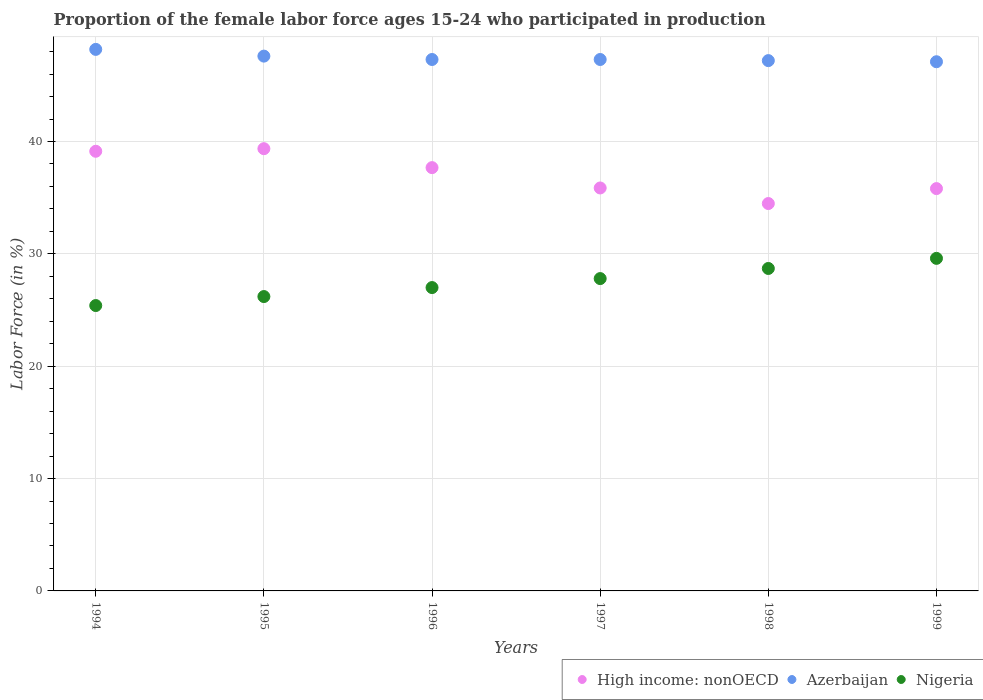How many different coloured dotlines are there?
Offer a very short reply. 3. Is the number of dotlines equal to the number of legend labels?
Your answer should be very brief. Yes. What is the proportion of the female labor force who participated in production in High income: nonOECD in 1998?
Provide a short and direct response. 34.48. Across all years, what is the maximum proportion of the female labor force who participated in production in Azerbaijan?
Your answer should be compact. 48.2. Across all years, what is the minimum proportion of the female labor force who participated in production in Nigeria?
Keep it short and to the point. 25.4. In which year was the proportion of the female labor force who participated in production in High income: nonOECD minimum?
Offer a terse response. 1998. What is the total proportion of the female labor force who participated in production in Nigeria in the graph?
Offer a terse response. 164.7. What is the difference between the proportion of the female labor force who participated in production in High income: nonOECD in 1997 and that in 1998?
Your answer should be very brief. 1.39. What is the difference between the proportion of the female labor force who participated in production in Nigeria in 1994 and the proportion of the female labor force who participated in production in High income: nonOECD in 1997?
Give a very brief answer. -10.47. What is the average proportion of the female labor force who participated in production in High income: nonOECD per year?
Your response must be concise. 37.05. In the year 1998, what is the difference between the proportion of the female labor force who participated in production in High income: nonOECD and proportion of the female labor force who participated in production in Azerbaijan?
Provide a succinct answer. -12.72. What is the ratio of the proportion of the female labor force who participated in production in Azerbaijan in 1995 to that in 1996?
Provide a short and direct response. 1.01. Is the proportion of the female labor force who participated in production in Nigeria in 1997 less than that in 1999?
Keep it short and to the point. Yes. What is the difference between the highest and the second highest proportion of the female labor force who participated in production in Azerbaijan?
Your response must be concise. 0.6. What is the difference between the highest and the lowest proportion of the female labor force who participated in production in Nigeria?
Provide a succinct answer. 4.2. Is the sum of the proportion of the female labor force who participated in production in High income: nonOECD in 1996 and 1999 greater than the maximum proportion of the female labor force who participated in production in Azerbaijan across all years?
Your response must be concise. Yes. Is it the case that in every year, the sum of the proportion of the female labor force who participated in production in High income: nonOECD and proportion of the female labor force who participated in production in Azerbaijan  is greater than the proportion of the female labor force who participated in production in Nigeria?
Your answer should be very brief. Yes. Does the proportion of the female labor force who participated in production in Azerbaijan monotonically increase over the years?
Give a very brief answer. No. How many dotlines are there?
Offer a terse response. 3. How many years are there in the graph?
Make the answer very short. 6. What is the difference between two consecutive major ticks on the Y-axis?
Ensure brevity in your answer.  10. Does the graph contain any zero values?
Provide a succinct answer. No. Where does the legend appear in the graph?
Your answer should be very brief. Bottom right. What is the title of the graph?
Keep it short and to the point. Proportion of the female labor force ages 15-24 who participated in production. Does "Seychelles" appear as one of the legend labels in the graph?
Keep it short and to the point. No. What is the label or title of the X-axis?
Make the answer very short. Years. What is the label or title of the Y-axis?
Ensure brevity in your answer.  Labor Force (in %). What is the Labor Force (in %) in High income: nonOECD in 1994?
Make the answer very short. 39.13. What is the Labor Force (in %) in Azerbaijan in 1994?
Provide a short and direct response. 48.2. What is the Labor Force (in %) of Nigeria in 1994?
Give a very brief answer. 25.4. What is the Labor Force (in %) in High income: nonOECD in 1995?
Make the answer very short. 39.36. What is the Labor Force (in %) of Azerbaijan in 1995?
Provide a short and direct response. 47.6. What is the Labor Force (in %) in Nigeria in 1995?
Your answer should be compact. 26.2. What is the Labor Force (in %) of High income: nonOECD in 1996?
Give a very brief answer. 37.68. What is the Labor Force (in %) of Azerbaijan in 1996?
Ensure brevity in your answer.  47.3. What is the Labor Force (in %) of Nigeria in 1996?
Your answer should be very brief. 27. What is the Labor Force (in %) of High income: nonOECD in 1997?
Your answer should be compact. 35.87. What is the Labor Force (in %) of Azerbaijan in 1997?
Make the answer very short. 47.3. What is the Labor Force (in %) of Nigeria in 1997?
Make the answer very short. 27.8. What is the Labor Force (in %) in High income: nonOECD in 1998?
Offer a very short reply. 34.48. What is the Labor Force (in %) of Azerbaijan in 1998?
Keep it short and to the point. 47.2. What is the Labor Force (in %) in Nigeria in 1998?
Give a very brief answer. 28.7. What is the Labor Force (in %) in High income: nonOECD in 1999?
Give a very brief answer. 35.81. What is the Labor Force (in %) of Azerbaijan in 1999?
Offer a terse response. 47.1. What is the Labor Force (in %) in Nigeria in 1999?
Offer a very short reply. 29.6. Across all years, what is the maximum Labor Force (in %) in High income: nonOECD?
Your answer should be compact. 39.36. Across all years, what is the maximum Labor Force (in %) of Azerbaijan?
Keep it short and to the point. 48.2. Across all years, what is the maximum Labor Force (in %) in Nigeria?
Make the answer very short. 29.6. Across all years, what is the minimum Labor Force (in %) in High income: nonOECD?
Ensure brevity in your answer.  34.48. Across all years, what is the minimum Labor Force (in %) of Azerbaijan?
Make the answer very short. 47.1. Across all years, what is the minimum Labor Force (in %) in Nigeria?
Provide a succinct answer. 25.4. What is the total Labor Force (in %) of High income: nonOECD in the graph?
Provide a succinct answer. 222.32. What is the total Labor Force (in %) of Azerbaijan in the graph?
Keep it short and to the point. 284.7. What is the total Labor Force (in %) of Nigeria in the graph?
Your response must be concise. 164.7. What is the difference between the Labor Force (in %) in High income: nonOECD in 1994 and that in 1995?
Give a very brief answer. -0.23. What is the difference between the Labor Force (in %) in Azerbaijan in 1994 and that in 1995?
Give a very brief answer. 0.6. What is the difference between the Labor Force (in %) in High income: nonOECD in 1994 and that in 1996?
Keep it short and to the point. 1.46. What is the difference between the Labor Force (in %) of Nigeria in 1994 and that in 1996?
Provide a succinct answer. -1.6. What is the difference between the Labor Force (in %) of High income: nonOECD in 1994 and that in 1997?
Your response must be concise. 3.27. What is the difference between the Labor Force (in %) of High income: nonOECD in 1994 and that in 1998?
Make the answer very short. 4.65. What is the difference between the Labor Force (in %) of Nigeria in 1994 and that in 1998?
Provide a succinct answer. -3.3. What is the difference between the Labor Force (in %) of High income: nonOECD in 1994 and that in 1999?
Make the answer very short. 3.32. What is the difference between the Labor Force (in %) in Azerbaijan in 1994 and that in 1999?
Offer a terse response. 1.1. What is the difference between the Labor Force (in %) in High income: nonOECD in 1995 and that in 1996?
Give a very brief answer. 1.69. What is the difference between the Labor Force (in %) in Azerbaijan in 1995 and that in 1996?
Provide a succinct answer. 0.3. What is the difference between the Labor Force (in %) in High income: nonOECD in 1995 and that in 1997?
Ensure brevity in your answer.  3.5. What is the difference between the Labor Force (in %) of Azerbaijan in 1995 and that in 1997?
Your answer should be very brief. 0.3. What is the difference between the Labor Force (in %) of High income: nonOECD in 1995 and that in 1998?
Offer a very short reply. 4.88. What is the difference between the Labor Force (in %) in Nigeria in 1995 and that in 1998?
Your answer should be compact. -2.5. What is the difference between the Labor Force (in %) in High income: nonOECD in 1995 and that in 1999?
Make the answer very short. 3.55. What is the difference between the Labor Force (in %) of Azerbaijan in 1995 and that in 1999?
Give a very brief answer. 0.5. What is the difference between the Labor Force (in %) in Nigeria in 1995 and that in 1999?
Offer a very short reply. -3.4. What is the difference between the Labor Force (in %) of High income: nonOECD in 1996 and that in 1997?
Offer a very short reply. 1.81. What is the difference between the Labor Force (in %) in High income: nonOECD in 1996 and that in 1998?
Offer a very short reply. 3.2. What is the difference between the Labor Force (in %) in Azerbaijan in 1996 and that in 1998?
Offer a very short reply. 0.1. What is the difference between the Labor Force (in %) of High income: nonOECD in 1996 and that in 1999?
Your answer should be compact. 1.87. What is the difference between the Labor Force (in %) of Nigeria in 1996 and that in 1999?
Offer a very short reply. -2.6. What is the difference between the Labor Force (in %) of High income: nonOECD in 1997 and that in 1998?
Your response must be concise. 1.39. What is the difference between the Labor Force (in %) of Azerbaijan in 1997 and that in 1998?
Provide a succinct answer. 0.1. What is the difference between the Labor Force (in %) in Nigeria in 1997 and that in 1998?
Offer a very short reply. -0.9. What is the difference between the Labor Force (in %) in High income: nonOECD in 1997 and that in 1999?
Your answer should be compact. 0.06. What is the difference between the Labor Force (in %) in Nigeria in 1997 and that in 1999?
Offer a terse response. -1.8. What is the difference between the Labor Force (in %) of High income: nonOECD in 1998 and that in 1999?
Provide a short and direct response. -1.33. What is the difference between the Labor Force (in %) of Azerbaijan in 1998 and that in 1999?
Provide a short and direct response. 0.1. What is the difference between the Labor Force (in %) of Nigeria in 1998 and that in 1999?
Keep it short and to the point. -0.9. What is the difference between the Labor Force (in %) in High income: nonOECD in 1994 and the Labor Force (in %) in Azerbaijan in 1995?
Your response must be concise. -8.47. What is the difference between the Labor Force (in %) in High income: nonOECD in 1994 and the Labor Force (in %) in Nigeria in 1995?
Give a very brief answer. 12.93. What is the difference between the Labor Force (in %) of Azerbaijan in 1994 and the Labor Force (in %) of Nigeria in 1995?
Provide a short and direct response. 22. What is the difference between the Labor Force (in %) of High income: nonOECD in 1994 and the Labor Force (in %) of Azerbaijan in 1996?
Provide a succinct answer. -8.17. What is the difference between the Labor Force (in %) in High income: nonOECD in 1994 and the Labor Force (in %) in Nigeria in 1996?
Give a very brief answer. 12.13. What is the difference between the Labor Force (in %) in Azerbaijan in 1994 and the Labor Force (in %) in Nigeria in 1996?
Provide a succinct answer. 21.2. What is the difference between the Labor Force (in %) of High income: nonOECD in 1994 and the Labor Force (in %) of Azerbaijan in 1997?
Provide a short and direct response. -8.17. What is the difference between the Labor Force (in %) of High income: nonOECD in 1994 and the Labor Force (in %) of Nigeria in 1997?
Your answer should be very brief. 11.33. What is the difference between the Labor Force (in %) in Azerbaijan in 1994 and the Labor Force (in %) in Nigeria in 1997?
Offer a terse response. 20.4. What is the difference between the Labor Force (in %) of High income: nonOECD in 1994 and the Labor Force (in %) of Azerbaijan in 1998?
Your answer should be very brief. -8.07. What is the difference between the Labor Force (in %) of High income: nonOECD in 1994 and the Labor Force (in %) of Nigeria in 1998?
Offer a terse response. 10.43. What is the difference between the Labor Force (in %) of High income: nonOECD in 1994 and the Labor Force (in %) of Azerbaijan in 1999?
Your answer should be very brief. -7.97. What is the difference between the Labor Force (in %) of High income: nonOECD in 1994 and the Labor Force (in %) of Nigeria in 1999?
Provide a succinct answer. 9.53. What is the difference between the Labor Force (in %) in High income: nonOECD in 1995 and the Labor Force (in %) in Azerbaijan in 1996?
Make the answer very short. -7.94. What is the difference between the Labor Force (in %) of High income: nonOECD in 1995 and the Labor Force (in %) of Nigeria in 1996?
Offer a very short reply. 12.36. What is the difference between the Labor Force (in %) of Azerbaijan in 1995 and the Labor Force (in %) of Nigeria in 1996?
Your answer should be compact. 20.6. What is the difference between the Labor Force (in %) in High income: nonOECD in 1995 and the Labor Force (in %) in Azerbaijan in 1997?
Give a very brief answer. -7.94. What is the difference between the Labor Force (in %) in High income: nonOECD in 1995 and the Labor Force (in %) in Nigeria in 1997?
Your answer should be compact. 11.56. What is the difference between the Labor Force (in %) of Azerbaijan in 1995 and the Labor Force (in %) of Nigeria in 1997?
Provide a succinct answer. 19.8. What is the difference between the Labor Force (in %) of High income: nonOECD in 1995 and the Labor Force (in %) of Azerbaijan in 1998?
Offer a terse response. -7.84. What is the difference between the Labor Force (in %) of High income: nonOECD in 1995 and the Labor Force (in %) of Nigeria in 1998?
Offer a very short reply. 10.66. What is the difference between the Labor Force (in %) of Azerbaijan in 1995 and the Labor Force (in %) of Nigeria in 1998?
Provide a succinct answer. 18.9. What is the difference between the Labor Force (in %) of High income: nonOECD in 1995 and the Labor Force (in %) of Azerbaijan in 1999?
Your response must be concise. -7.74. What is the difference between the Labor Force (in %) in High income: nonOECD in 1995 and the Labor Force (in %) in Nigeria in 1999?
Offer a terse response. 9.76. What is the difference between the Labor Force (in %) of High income: nonOECD in 1996 and the Labor Force (in %) of Azerbaijan in 1997?
Offer a terse response. -9.62. What is the difference between the Labor Force (in %) of High income: nonOECD in 1996 and the Labor Force (in %) of Nigeria in 1997?
Make the answer very short. 9.88. What is the difference between the Labor Force (in %) in Azerbaijan in 1996 and the Labor Force (in %) in Nigeria in 1997?
Offer a very short reply. 19.5. What is the difference between the Labor Force (in %) of High income: nonOECD in 1996 and the Labor Force (in %) of Azerbaijan in 1998?
Provide a short and direct response. -9.53. What is the difference between the Labor Force (in %) of High income: nonOECD in 1996 and the Labor Force (in %) of Nigeria in 1998?
Provide a short and direct response. 8.97. What is the difference between the Labor Force (in %) of Azerbaijan in 1996 and the Labor Force (in %) of Nigeria in 1998?
Provide a succinct answer. 18.6. What is the difference between the Labor Force (in %) of High income: nonOECD in 1996 and the Labor Force (in %) of Azerbaijan in 1999?
Ensure brevity in your answer.  -9.43. What is the difference between the Labor Force (in %) of High income: nonOECD in 1996 and the Labor Force (in %) of Nigeria in 1999?
Give a very brief answer. 8.07. What is the difference between the Labor Force (in %) in Azerbaijan in 1996 and the Labor Force (in %) in Nigeria in 1999?
Keep it short and to the point. 17.7. What is the difference between the Labor Force (in %) of High income: nonOECD in 1997 and the Labor Force (in %) of Azerbaijan in 1998?
Provide a succinct answer. -11.33. What is the difference between the Labor Force (in %) in High income: nonOECD in 1997 and the Labor Force (in %) in Nigeria in 1998?
Give a very brief answer. 7.17. What is the difference between the Labor Force (in %) in High income: nonOECD in 1997 and the Labor Force (in %) in Azerbaijan in 1999?
Give a very brief answer. -11.23. What is the difference between the Labor Force (in %) in High income: nonOECD in 1997 and the Labor Force (in %) in Nigeria in 1999?
Your answer should be very brief. 6.27. What is the difference between the Labor Force (in %) in High income: nonOECD in 1998 and the Labor Force (in %) in Azerbaijan in 1999?
Give a very brief answer. -12.62. What is the difference between the Labor Force (in %) in High income: nonOECD in 1998 and the Labor Force (in %) in Nigeria in 1999?
Make the answer very short. 4.88. What is the average Labor Force (in %) of High income: nonOECD per year?
Offer a very short reply. 37.05. What is the average Labor Force (in %) of Azerbaijan per year?
Ensure brevity in your answer.  47.45. What is the average Labor Force (in %) of Nigeria per year?
Make the answer very short. 27.45. In the year 1994, what is the difference between the Labor Force (in %) in High income: nonOECD and Labor Force (in %) in Azerbaijan?
Ensure brevity in your answer.  -9.07. In the year 1994, what is the difference between the Labor Force (in %) of High income: nonOECD and Labor Force (in %) of Nigeria?
Provide a short and direct response. 13.73. In the year 1994, what is the difference between the Labor Force (in %) of Azerbaijan and Labor Force (in %) of Nigeria?
Keep it short and to the point. 22.8. In the year 1995, what is the difference between the Labor Force (in %) of High income: nonOECD and Labor Force (in %) of Azerbaijan?
Your response must be concise. -8.24. In the year 1995, what is the difference between the Labor Force (in %) in High income: nonOECD and Labor Force (in %) in Nigeria?
Keep it short and to the point. 13.16. In the year 1995, what is the difference between the Labor Force (in %) of Azerbaijan and Labor Force (in %) of Nigeria?
Your response must be concise. 21.4. In the year 1996, what is the difference between the Labor Force (in %) in High income: nonOECD and Labor Force (in %) in Azerbaijan?
Offer a terse response. -9.62. In the year 1996, what is the difference between the Labor Force (in %) in High income: nonOECD and Labor Force (in %) in Nigeria?
Offer a very short reply. 10.68. In the year 1996, what is the difference between the Labor Force (in %) in Azerbaijan and Labor Force (in %) in Nigeria?
Offer a terse response. 20.3. In the year 1997, what is the difference between the Labor Force (in %) of High income: nonOECD and Labor Force (in %) of Azerbaijan?
Keep it short and to the point. -11.43. In the year 1997, what is the difference between the Labor Force (in %) of High income: nonOECD and Labor Force (in %) of Nigeria?
Make the answer very short. 8.07. In the year 1997, what is the difference between the Labor Force (in %) of Azerbaijan and Labor Force (in %) of Nigeria?
Offer a very short reply. 19.5. In the year 1998, what is the difference between the Labor Force (in %) of High income: nonOECD and Labor Force (in %) of Azerbaijan?
Offer a terse response. -12.72. In the year 1998, what is the difference between the Labor Force (in %) of High income: nonOECD and Labor Force (in %) of Nigeria?
Your answer should be compact. 5.78. In the year 1998, what is the difference between the Labor Force (in %) of Azerbaijan and Labor Force (in %) of Nigeria?
Your response must be concise. 18.5. In the year 1999, what is the difference between the Labor Force (in %) in High income: nonOECD and Labor Force (in %) in Azerbaijan?
Give a very brief answer. -11.29. In the year 1999, what is the difference between the Labor Force (in %) in High income: nonOECD and Labor Force (in %) in Nigeria?
Your answer should be compact. 6.21. What is the ratio of the Labor Force (in %) of Azerbaijan in 1994 to that in 1995?
Provide a short and direct response. 1.01. What is the ratio of the Labor Force (in %) of Nigeria in 1994 to that in 1995?
Offer a terse response. 0.97. What is the ratio of the Labor Force (in %) of High income: nonOECD in 1994 to that in 1996?
Provide a succinct answer. 1.04. What is the ratio of the Labor Force (in %) in Nigeria in 1994 to that in 1996?
Provide a succinct answer. 0.94. What is the ratio of the Labor Force (in %) of High income: nonOECD in 1994 to that in 1997?
Your response must be concise. 1.09. What is the ratio of the Labor Force (in %) in Azerbaijan in 1994 to that in 1997?
Your response must be concise. 1.02. What is the ratio of the Labor Force (in %) of Nigeria in 1994 to that in 1997?
Ensure brevity in your answer.  0.91. What is the ratio of the Labor Force (in %) of High income: nonOECD in 1994 to that in 1998?
Your answer should be very brief. 1.13. What is the ratio of the Labor Force (in %) of Azerbaijan in 1994 to that in 1998?
Offer a terse response. 1.02. What is the ratio of the Labor Force (in %) of Nigeria in 1994 to that in 1998?
Provide a succinct answer. 0.89. What is the ratio of the Labor Force (in %) in High income: nonOECD in 1994 to that in 1999?
Ensure brevity in your answer.  1.09. What is the ratio of the Labor Force (in %) in Azerbaijan in 1994 to that in 1999?
Offer a very short reply. 1.02. What is the ratio of the Labor Force (in %) of Nigeria in 1994 to that in 1999?
Keep it short and to the point. 0.86. What is the ratio of the Labor Force (in %) in High income: nonOECD in 1995 to that in 1996?
Provide a succinct answer. 1.04. What is the ratio of the Labor Force (in %) in Azerbaijan in 1995 to that in 1996?
Provide a succinct answer. 1.01. What is the ratio of the Labor Force (in %) in Nigeria in 1995 to that in 1996?
Keep it short and to the point. 0.97. What is the ratio of the Labor Force (in %) in High income: nonOECD in 1995 to that in 1997?
Make the answer very short. 1.1. What is the ratio of the Labor Force (in %) of Nigeria in 1995 to that in 1997?
Offer a terse response. 0.94. What is the ratio of the Labor Force (in %) in High income: nonOECD in 1995 to that in 1998?
Give a very brief answer. 1.14. What is the ratio of the Labor Force (in %) of Azerbaijan in 1995 to that in 1998?
Offer a very short reply. 1.01. What is the ratio of the Labor Force (in %) in Nigeria in 1995 to that in 1998?
Give a very brief answer. 0.91. What is the ratio of the Labor Force (in %) of High income: nonOECD in 1995 to that in 1999?
Give a very brief answer. 1.1. What is the ratio of the Labor Force (in %) in Azerbaijan in 1995 to that in 1999?
Provide a succinct answer. 1.01. What is the ratio of the Labor Force (in %) of Nigeria in 1995 to that in 1999?
Provide a short and direct response. 0.89. What is the ratio of the Labor Force (in %) of High income: nonOECD in 1996 to that in 1997?
Make the answer very short. 1.05. What is the ratio of the Labor Force (in %) in Azerbaijan in 1996 to that in 1997?
Ensure brevity in your answer.  1. What is the ratio of the Labor Force (in %) of Nigeria in 1996 to that in 1997?
Provide a short and direct response. 0.97. What is the ratio of the Labor Force (in %) of High income: nonOECD in 1996 to that in 1998?
Your answer should be compact. 1.09. What is the ratio of the Labor Force (in %) of Nigeria in 1996 to that in 1998?
Your response must be concise. 0.94. What is the ratio of the Labor Force (in %) in High income: nonOECD in 1996 to that in 1999?
Give a very brief answer. 1.05. What is the ratio of the Labor Force (in %) in Nigeria in 1996 to that in 1999?
Make the answer very short. 0.91. What is the ratio of the Labor Force (in %) in High income: nonOECD in 1997 to that in 1998?
Your response must be concise. 1.04. What is the ratio of the Labor Force (in %) of Nigeria in 1997 to that in 1998?
Your answer should be very brief. 0.97. What is the ratio of the Labor Force (in %) in Azerbaijan in 1997 to that in 1999?
Your answer should be very brief. 1. What is the ratio of the Labor Force (in %) of Nigeria in 1997 to that in 1999?
Your response must be concise. 0.94. What is the ratio of the Labor Force (in %) of High income: nonOECD in 1998 to that in 1999?
Ensure brevity in your answer.  0.96. What is the ratio of the Labor Force (in %) in Azerbaijan in 1998 to that in 1999?
Ensure brevity in your answer.  1. What is the ratio of the Labor Force (in %) in Nigeria in 1998 to that in 1999?
Keep it short and to the point. 0.97. What is the difference between the highest and the second highest Labor Force (in %) in High income: nonOECD?
Provide a succinct answer. 0.23. What is the difference between the highest and the second highest Labor Force (in %) in Azerbaijan?
Your response must be concise. 0.6. What is the difference between the highest and the lowest Labor Force (in %) in High income: nonOECD?
Your answer should be compact. 4.88. What is the difference between the highest and the lowest Labor Force (in %) in Azerbaijan?
Give a very brief answer. 1.1. 